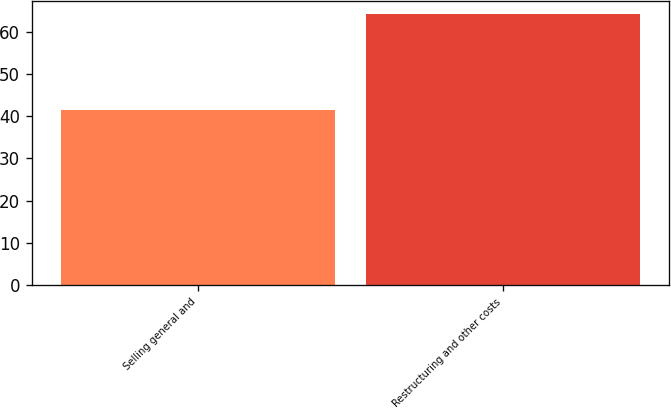<chart> <loc_0><loc_0><loc_500><loc_500><bar_chart><fcel>Selling general and<fcel>Restructuring and other costs<nl><fcel>41.4<fcel>64.1<nl></chart> 